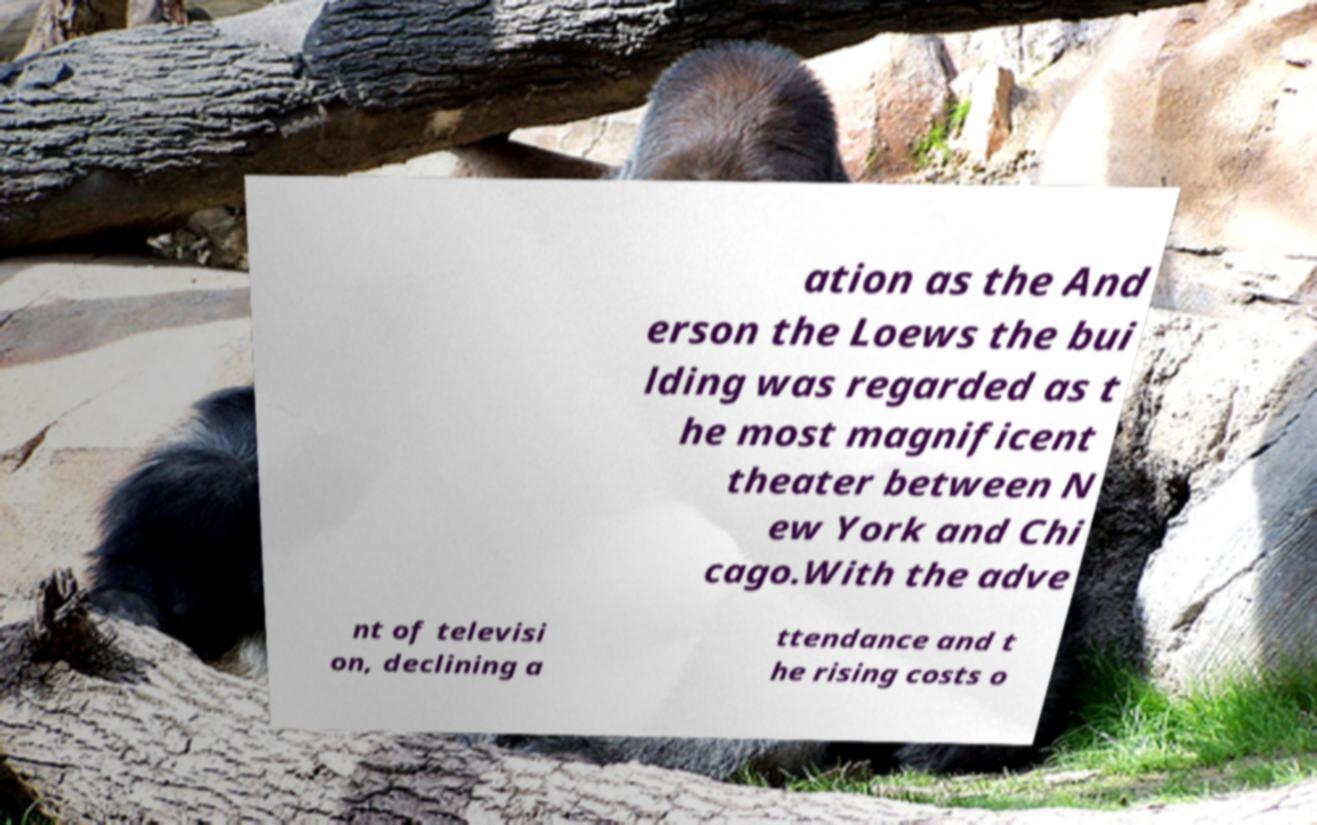For documentation purposes, I need the text within this image transcribed. Could you provide that? ation as the And erson the Loews the bui lding was regarded as t he most magnificent theater between N ew York and Chi cago.With the adve nt of televisi on, declining a ttendance and t he rising costs o 